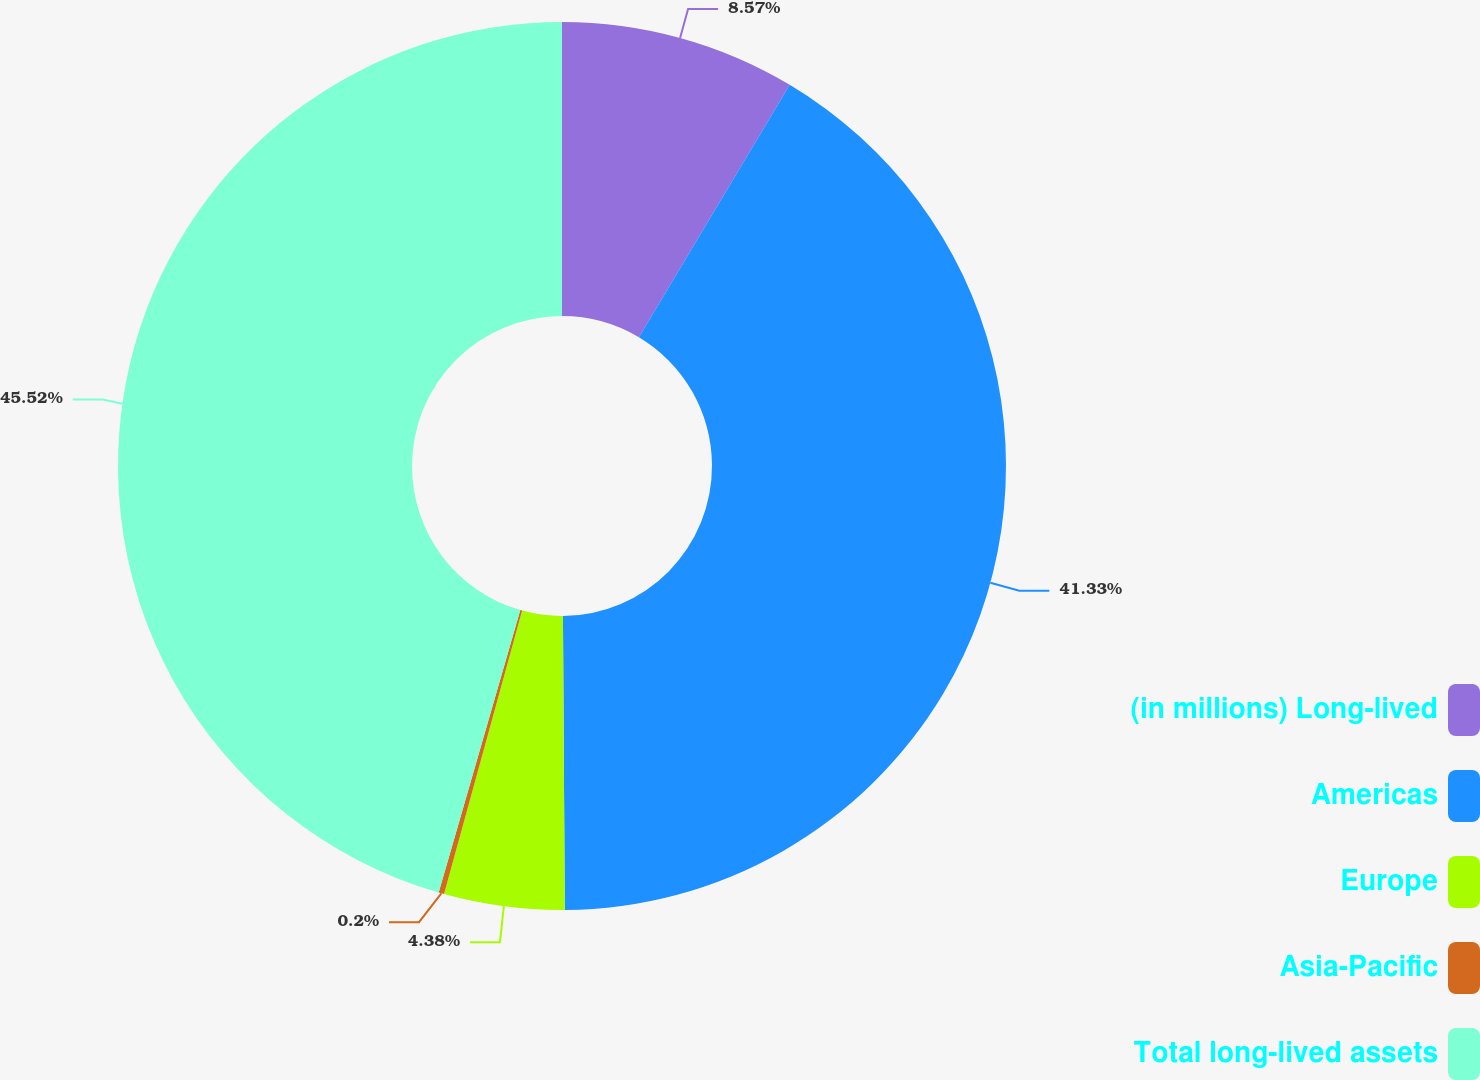Convert chart to OTSL. <chart><loc_0><loc_0><loc_500><loc_500><pie_chart><fcel>(in millions) Long-lived<fcel>Americas<fcel>Europe<fcel>Asia-Pacific<fcel>Total long-lived assets<nl><fcel>8.57%<fcel>41.33%<fcel>4.38%<fcel>0.2%<fcel>45.52%<nl></chart> 